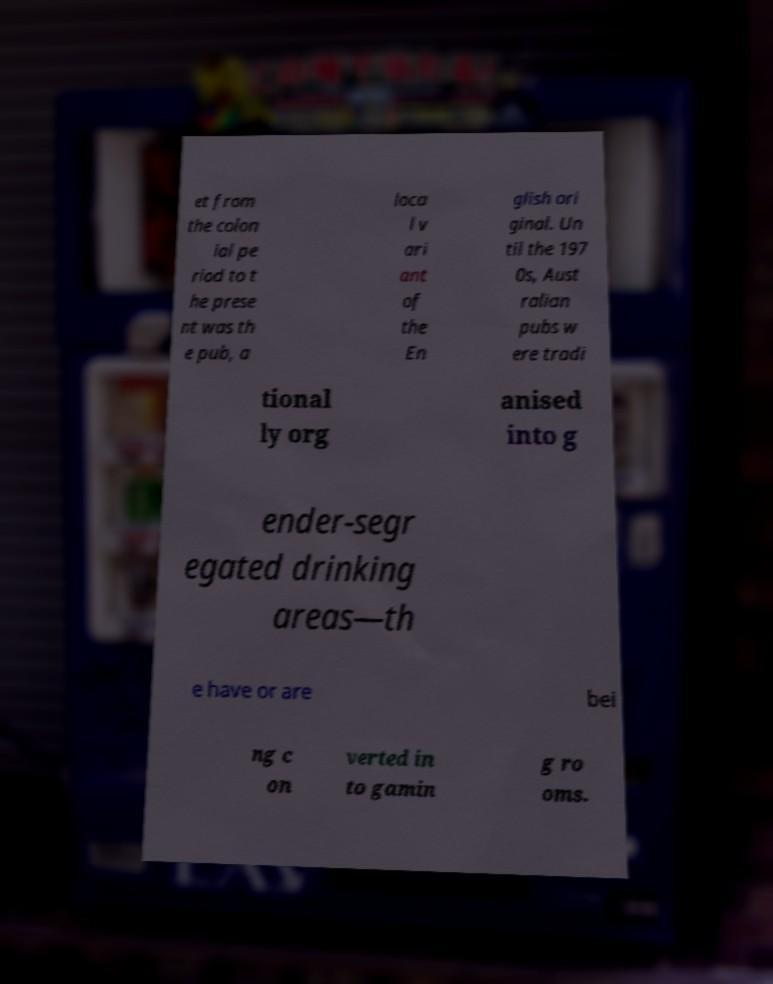Please read and relay the text visible in this image. What does it say? et from the colon ial pe riod to t he prese nt was th e pub, a loca l v ari ant of the En glish ori ginal. Un til the 197 0s, Aust ralian pubs w ere tradi tional ly org anised into g ender-segr egated drinking areas—th e have or are bei ng c on verted in to gamin g ro oms. 